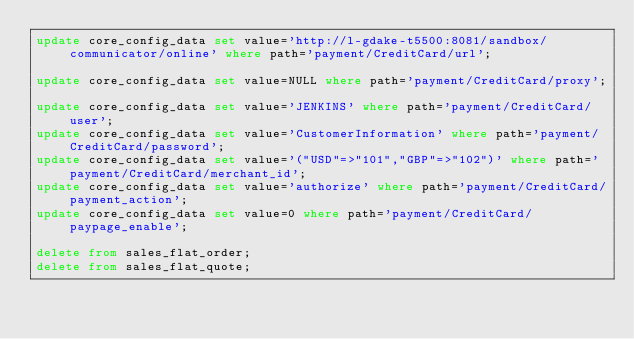Convert code to text. <code><loc_0><loc_0><loc_500><loc_500><_SQL_>update core_config_data set value='http://l-gdake-t5500:8081/sandbox/communicator/online' where path='payment/CreditCard/url';

update core_config_data set value=NULL where path='payment/CreditCard/proxy';

update core_config_data set value='JENKINS' where path='payment/CreditCard/user';
update core_config_data set value='CustomerInformation' where path='payment/CreditCard/password';
update core_config_data set value='("USD"=>"101","GBP"=>"102")' where path='payment/CreditCard/merchant_id';
update core_config_data set value='authorize' where path='payment/CreditCard/payment_action';
update core_config_data set value=0 where path='payment/CreditCard/paypage_enable';

delete from sales_flat_order;
delete from sales_flat_quote;
</code> 